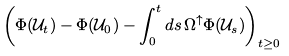<formula> <loc_0><loc_0><loc_500><loc_500>& \left ( \Phi ( { \mathcal { U } } _ { t } ) - \Phi ( { \mathcal { U } } _ { 0 } ) - \int ^ { t } _ { 0 } d s \, \Omega ^ { \uparrow } \Phi ( { \mathcal { U } } _ { s } ) \right ) _ { t \geq 0 }</formula> 